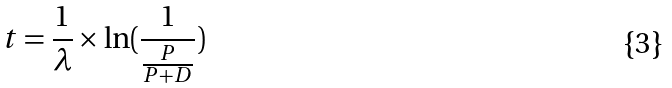<formula> <loc_0><loc_0><loc_500><loc_500>t = \frac { 1 } { \lambda } \times \ln ( \frac { 1 } { \frac { P } { P + D } } )</formula> 